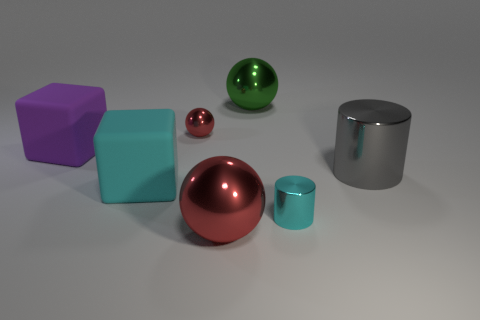Is there a red sphere?
Your answer should be very brief. Yes. The metal cylinder behind the cylinder that is in front of the gray object is what color?
Offer a very short reply. Gray. How many other things are there of the same color as the tiny metal sphere?
Ensure brevity in your answer.  1. What number of things are purple spheres or metallic things to the left of the cyan cylinder?
Ensure brevity in your answer.  3. What color is the thing that is behind the small metallic sphere?
Your response must be concise. Green. What is the shape of the small red thing?
Provide a short and direct response. Sphere. What is the material of the large sphere in front of the red metallic object behind the large cylinder?
Provide a succinct answer. Metal. What number of other things are there of the same material as the tiny red object
Provide a succinct answer. 4. There is a cyan object that is the same size as the green shiny ball; what is it made of?
Your response must be concise. Rubber. Is the number of small red metallic things to the left of the cyan matte block greater than the number of purple objects in front of the big red metal object?
Make the answer very short. No. 